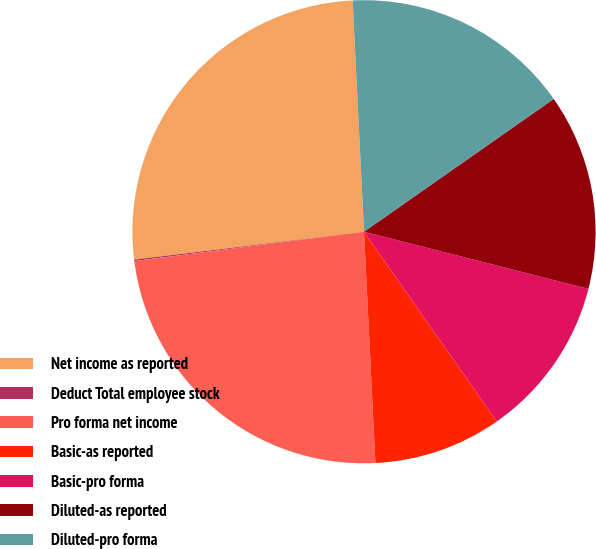Convert chart. <chart><loc_0><loc_0><loc_500><loc_500><pie_chart><fcel>Net income as reported<fcel>Deduct Total employee stock<fcel>Pro forma net income<fcel>Basic-as reported<fcel>Basic-pro forma<fcel>Diluted-as reported<fcel>Diluted-pro forma<nl><fcel>26.14%<fcel>0.1%<fcel>23.76%<fcel>8.94%<fcel>11.31%<fcel>13.69%<fcel>16.06%<nl></chart> 